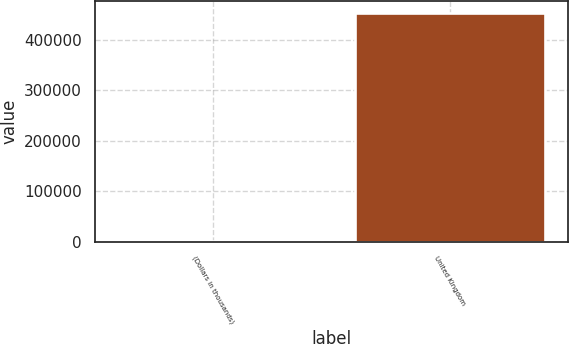<chart> <loc_0><loc_0><loc_500><loc_500><bar_chart><fcel>(Dollars in thousands)<fcel>United Kingdom<nl><fcel>2011<fcel>453169<nl></chart> 